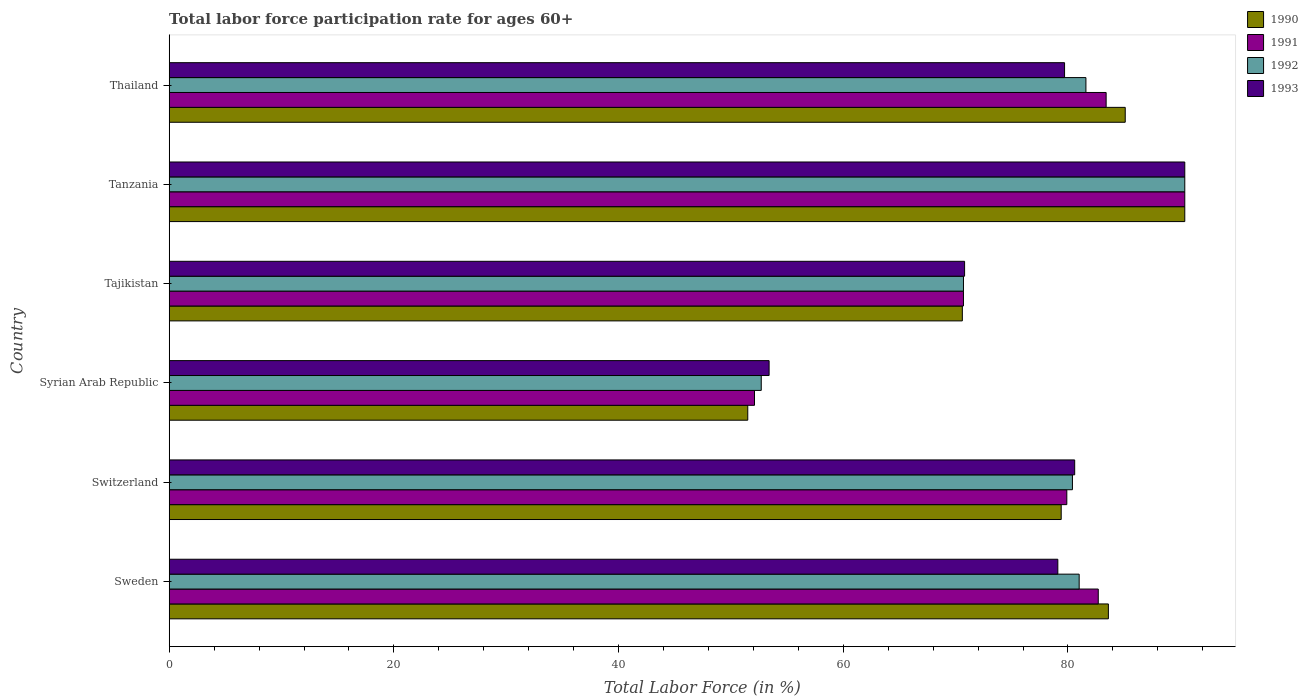How many different coloured bars are there?
Provide a short and direct response. 4. What is the label of the 1st group of bars from the top?
Your answer should be compact. Thailand. What is the labor force participation rate in 1990 in Sweden?
Make the answer very short. 83.6. Across all countries, what is the maximum labor force participation rate in 1991?
Your answer should be compact. 90.4. Across all countries, what is the minimum labor force participation rate in 1992?
Provide a succinct answer. 52.7. In which country was the labor force participation rate in 1992 maximum?
Provide a succinct answer. Tanzania. In which country was the labor force participation rate in 1991 minimum?
Provide a succinct answer. Syrian Arab Republic. What is the total labor force participation rate in 1990 in the graph?
Offer a very short reply. 460.6. What is the difference between the labor force participation rate in 1990 in Tajikistan and that in Thailand?
Give a very brief answer. -14.5. What is the difference between the labor force participation rate in 1992 in Tajikistan and the labor force participation rate in 1991 in Sweden?
Give a very brief answer. -12. What is the average labor force participation rate in 1991 per country?
Keep it short and to the point. 76.53. What is the difference between the labor force participation rate in 1990 and labor force participation rate in 1993 in Thailand?
Provide a short and direct response. 5.4. In how many countries, is the labor force participation rate in 1991 greater than 12 %?
Offer a terse response. 6. What is the ratio of the labor force participation rate in 1991 in Switzerland to that in Tajikistan?
Provide a succinct answer. 1.13. What is the difference between the highest and the second highest labor force participation rate in 1993?
Offer a very short reply. 9.8. What is the difference between the highest and the lowest labor force participation rate in 1990?
Offer a very short reply. 38.9. Is it the case that in every country, the sum of the labor force participation rate in 1990 and labor force participation rate in 1992 is greater than the sum of labor force participation rate in 1991 and labor force participation rate in 1993?
Offer a very short reply. No. What does the 1st bar from the top in Tajikistan represents?
Make the answer very short. 1993. How many bars are there?
Give a very brief answer. 24. Are all the bars in the graph horizontal?
Your answer should be very brief. Yes. How many countries are there in the graph?
Your answer should be very brief. 6. Does the graph contain any zero values?
Your answer should be compact. No. Does the graph contain grids?
Make the answer very short. No. Where does the legend appear in the graph?
Your answer should be very brief. Top right. How many legend labels are there?
Make the answer very short. 4. What is the title of the graph?
Your answer should be compact. Total labor force participation rate for ages 60+. What is the label or title of the X-axis?
Ensure brevity in your answer.  Total Labor Force (in %). What is the Total Labor Force (in %) of 1990 in Sweden?
Keep it short and to the point. 83.6. What is the Total Labor Force (in %) of 1991 in Sweden?
Provide a short and direct response. 82.7. What is the Total Labor Force (in %) of 1993 in Sweden?
Offer a very short reply. 79.1. What is the Total Labor Force (in %) of 1990 in Switzerland?
Give a very brief answer. 79.4. What is the Total Labor Force (in %) in 1991 in Switzerland?
Provide a succinct answer. 79.9. What is the Total Labor Force (in %) of 1992 in Switzerland?
Your response must be concise. 80.4. What is the Total Labor Force (in %) in 1993 in Switzerland?
Offer a very short reply. 80.6. What is the Total Labor Force (in %) of 1990 in Syrian Arab Republic?
Your answer should be compact. 51.5. What is the Total Labor Force (in %) in 1991 in Syrian Arab Republic?
Give a very brief answer. 52.1. What is the Total Labor Force (in %) in 1992 in Syrian Arab Republic?
Your answer should be very brief. 52.7. What is the Total Labor Force (in %) in 1993 in Syrian Arab Republic?
Offer a terse response. 53.4. What is the Total Labor Force (in %) of 1990 in Tajikistan?
Provide a short and direct response. 70.6. What is the Total Labor Force (in %) in 1991 in Tajikistan?
Provide a short and direct response. 70.7. What is the Total Labor Force (in %) of 1992 in Tajikistan?
Your response must be concise. 70.7. What is the Total Labor Force (in %) in 1993 in Tajikistan?
Your answer should be compact. 70.8. What is the Total Labor Force (in %) in 1990 in Tanzania?
Provide a succinct answer. 90.4. What is the Total Labor Force (in %) in 1991 in Tanzania?
Your response must be concise. 90.4. What is the Total Labor Force (in %) of 1992 in Tanzania?
Provide a short and direct response. 90.4. What is the Total Labor Force (in %) in 1993 in Tanzania?
Ensure brevity in your answer.  90.4. What is the Total Labor Force (in %) in 1990 in Thailand?
Ensure brevity in your answer.  85.1. What is the Total Labor Force (in %) in 1991 in Thailand?
Give a very brief answer. 83.4. What is the Total Labor Force (in %) in 1992 in Thailand?
Ensure brevity in your answer.  81.6. What is the Total Labor Force (in %) in 1993 in Thailand?
Keep it short and to the point. 79.7. Across all countries, what is the maximum Total Labor Force (in %) of 1990?
Ensure brevity in your answer.  90.4. Across all countries, what is the maximum Total Labor Force (in %) of 1991?
Your response must be concise. 90.4. Across all countries, what is the maximum Total Labor Force (in %) in 1992?
Provide a short and direct response. 90.4. Across all countries, what is the maximum Total Labor Force (in %) in 1993?
Provide a short and direct response. 90.4. Across all countries, what is the minimum Total Labor Force (in %) in 1990?
Make the answer very short. 51.5. Across all countries, what is the minimum Total Labor Force (in %) in 1991?
Your answer should be very brief. 52.1. Across all countries, what is the minimum Total Labor Force (in %) of 1992?
Offer a terse response. 52.7. Across all countries, what is the minimum Total Labor Force (in %) of 1993?
Offer a very short reply. 53.4. What is the total Total Labor Force (in %) in 1990 in the graph?
Your response must be concise. 460.6. What is the total Total Labor Force (in %) in 1991 in the graph?
Your answer should be very brief. 459.2. What is the total Total Labor Force (in %) of 1992 in the graph?
Offer a terse response. 456.8. What is the total Total Labor Force (in %) in 1993 in the graph?
Ensure brevity in your answer.  454. What is the difference between the Total Labor Force (in %) in 1990 in Sweden and that in Switzerland?
Make the answer very short. 4.2. What is the difference between the Total Labor Force (in %) in 1991 in Sweden and that in Switzerland?
Provide a succinct answer. 2.8. What is the difference between the Total Labor Force (in %) of 1993 in Sweden and that in Switzerland?
Give a very brief answer. -1.5. What is the difference between the Total Labor Force (in %) of 1990 in Sweden and that in Syrian Arab Republic?
Your response must be concise. 32.1. What is the difference between the Total Labor Force (in %) in 1991 in Sweden and that in Syrian Arab Republic?
Offer a very short reply. 30.6. What is the difference between the Total Labor Force (in %) in 1992 in Sweden and that in Syrian Arab Republic?
Offer a terse response. 28.3. What is the difference between the Total Labor Force (in %) in 1993 in Sweden and that in Syrian Arab Republic?
Provide a short and direct response. 25.7. What is the difference between the Total Labor Force (in %) in 1990 in Sweden and that in Tajikistan?
Your response must be concise. 13. What is the difference between the Total Labor Force (in %) of 1991 in Sweden and that in Tajikistan?
Your answer should be very brief. 12. What is the difference between the Total Labor Force (in %) of 1992 in Sweden and that in Tajikistan?
Your response must be concise. 10.3. What is the difference between the Total Labor Force (in %) in 1990 in Sweden and that in Tanzania?
Offer a terse response. -6.8. What is the difference between the Total Labor Force (in %) in 1991 in Sweden and that in Tanzania?
Offer a very short reply. -7.7. What is the difference between the Total Labor Force (in %) in 1993 in Sweden and that in Tanzania?
Give a very brief answer. -11.3. What is the difference between the Total Labor Force (in %) of 1990 in Sweden and that in Thailand?
Provide a short and direct response. -1.5. What is the difference between the Total Labor Force (in %) in 1991 in Sweden and that in Thailand?
Your answer should be very brief. -0.7. What is the difference between the Total Labor Force (in %) of 1993 in Sweden and that in Thailand?
Provide a succinct answer. -0.6. What is the difference between the Total Labor Force (in %) in 1990 in Switzerland and that in Syrian Arab Republic?
Your response must be concise. 27.9. What is the difference between the Total Labor Force (in %) of 1991 in Switzerland and that in Syrian Arab Republic?
Your response must be concise. 27.8. What is the difference between the Total Labor Force (in %) of 1992 in Switzerland and that in Syrian Arab Republic?
Ensure brevity in your answer.  27.7. What is the difference between the Total Labor Force (in %) of 1993 in Switzerland and that in Syrian Arab Republic?
Offer a very short reply. 27.2. What is the difference between the Total Labor Force (in %) of 1992 in Switzerland and that in Tanzania?
Your response must be concise. -10. What is the difference between the Total Labor Force (in %) of 1990 in Switzerland and that in Thailand?
Your answer should be compact. -5.7. What is the difference between the Total Labor Force (in %) in 1990 in Syrian Arab Republic and that in Tajikistan?
Provide a succinct answer. -19.1. What is the difference between the Total Labor Force (in %) in 1991 in Syrian Arab Republic and that in Tajikistan?
Provide a succinct answer. -18.6. What is the difference between the Total Labor Force (in %) in 1993 in Syrian Arab Republic and that in Tajikistan?
Provide a short and direct response. -17.4. What is the difference between the Total Labor Force (in %) of 1990 in Syrian Arab Republic and that in Tanzania?
Give a very brief answer. -38.9. What is the difference between the Total Labor Force (in %) of 1991 in Syrian Arab Republic and that in Tanzania?
Provide a succinct answer. -38.3. What is the difference between the Total Labor Force (in %) in 1992 in Syrian Arab Republic and that in Tanzania?
Keep it short and to the point. -37.7. What is the difference between the Total Labor Force (in %) in 1993 in Syrian Arab Republic and that in Tanzania?
Offer a very short reply. -37. What is the difference between the Total Labor Force (in %) in 1990 in Syrian Arab Republic and that in Thailand?
Provide a short and direct response. -33.6. What is the difference between the Total Labor Force (in %) in 1991 in Syrian Arab Republic and that in Thailand?
Keep it short and to the point. -31.3. What is the difference between the Total Labor Force (in %) of 1992 in Syrian Arab Republic and that in Thailand?
Offer a very short reply. -28.9. What is the difference between the Total Labor Force (in %) of 1993 in Syrian Arab Republic and that in Thailand?
Ensure brevity in your answer.  -26.3. What is the difference between the Total Labor Force (in %) in 1990 in Tajikistan and that in Tanzania?
Ensure brevity in your answer.  -19.8. What is the difference between the Total Labor Force (in %) in 1991 in Tajikistan and that in Tanzania?
Your answer should be very brief. -19.7. What is the difference between the Total Labor Force (in %) in 1992 in Tajikistan and that in Tanzania?
Provide a succinct answer. -19.7. What is the difference between the Total Labor Force (in %) in 1993 in Tajikistan and that in Tanzania?
Your response must be concise. -19.6. What is the difference between the Total Labor Force (in %) in 1993 in Tajikistan and that in Thailand?
Offer a terse response. -8.9. What is the difference between the Total Labor Force (in %) in 1990 in Tanzania and that in Thailand?
Make the answer very short. 5.3. What is the difference between the Total Labor Force (in %) in 1991 in Tanzania and that in Thailand?
Offer a terse response. 7. What is the difference between the Total Labor Force (in %) of 1992 in Tanzania and that in Thailand?
Offer a terse response. 8.8. What is the difference between the Total Labor Force (in %) of 1993 in Tanzania and that in Thailand?
Give a very brief answer. 10.7. What is the difference between the Total Labor Force (in %) of 1990 in Sweden and the Total Labor Force (in %) of 1992 in Switzerland?
Your answer should be very brief. 3.2. What is the difference between the Total Labor Force (in %) in 1990 in Sweden and the Total Labor Force (in %) in 1993 in Switzerland?
Provide a succinct answer. 3. What is the difference between the Total Labor Force (in %) in 1991 in Sweden and the Total Labor Force (in %) in 1992 in Switzerland?
Your answer should be compact. 2.3. What is the difference between the Total Labor Force (in %) of 1991 in Sweden and the Total Labor Force (in %) of 1993 in Switzerland?
Your answer should be compact. 2.1. What is the difference between the Total Labor Force (in %) in 1990 in Sweden and the Total Labor Force (in %) in 1991 in Syrian Arab Republic?
Your answer should be compact. 31.5. What is the difference between the Total Labor Force (in %) in 1990 in Sweden and the Total Labor Force (in %) in 1992 in Syrian Arab Republic?
Offer a terse response. 30.9. What is the difference between the Total Labor Force (in %) in 1990 in Sweden and the Total Labor Force (in %) in 1993 in Syrian Arab Republic?
Provide a succinct answer. 30.2. What is the difference between the Total Labor Force (in %) of 1991 in Sweden and the Total Labor Force (in %) of 1992 in Syrian Arab Republic?
Provide a succinct answer. 30. What is the difference between the Total Labor Force (in %) of 1991 in Sweden and the Total Labor Force (in %) of 1993 in Syrian Arab Republic?
Provide a succinct answer. 29.3. What is the difference between the Total Labor Force (in %) in 1992 in Sweden and the Total Labor Force (in %) in 1993 in Syrian Arab Republic?
Keep it short and to the point. 27.6. What is the difference between the Total Labor Force (in %) in 1990 in Sweden and the Total Labor Force (in %) in 1991 in Tajikistan?
Provide a short and direct response. 12.9. What is the difference between the Total Labor Force (in %) in 1990 in Sweden and the Total Labor Force (in %) in 1993 in Tajikistan?
Keep it short and to the point. 12.8. What is the difference between the Total Labor Force (in %) in 1991 in Sweden and the Total Labor Force (in %) in 1992 in Tajikistan?
Your response must be concise. 12. What is the difference between the Total Labor Force (in %) of 1991 in Sweden and the Total Labor Force (in %) of 1993 in Tajikistan?
Keep it short and to the point. 11.9. What is the difference between the Total Labor Force (in %) in 1992 in Sweden and the Total Labor Force (in %) in 1993 in Tajikistan?
Ensure brevity in your answer.  10.2. What is the difference between the Total Labor Force (in %) of 1990 in Sweden and the Total Labor Force (in %) of 1993 in Tanzania?
Your response must be concise. -6.8. What is the difference between the Total Labor Force (in %) in 1992 in Sweden and the Total Labor Force (in %) in 1993 in Tanzania?
Provide a short and direct response. -9.4. What is the difference between the Total Labor Force (in %) of 1990 in Sweden and the Total Labor Force (in %) of 1992 in Thailand?
Your response must be concise. 2. What is the difference between the Total Labor Force (in %) in 1990 in Sweden and the Total Labor Force (in %) in 1993 in Thailand?
Provide a short and direct response. 3.9. What is the difference between the Total Labor Force (in %) of 1991 in Sweden and the Total Labor Force (in %) of 1993 in Thailand?
Your answer should be very brief. 3. What is the difference between the Total Labor Force (in %) of 1990 in Switzerland and the Total Labor Force (in %) of 1991 in Syrian Arab Republic?
Provide a short and direct response. 27.3. What is the difference between the Total Labor Force (in %) in 1990 in Switzerland and the Total Labor Force (in %) in 1992 in Syrian Arab Republic?
Give a very brief answer. 26.7. What is the difference between the Total Labor Force (in %) of 1990 in Switzerland and the Total Labor Force (in %) of 1993 in Syrian Arab Republic?
Offer a very short reply. 26. What is the difference between the Total Labor Force (in %) of 1991 in Switzerland and the Total Labor Force (in %) of 1992 in Syrian Arab Republic?
Offer a terse response. 27.2. What is the difference between the Total Labor Force (in %) in 1991 in Switzerland and the Total Labor Force (in %) in 1993 in Syrian Arab Republic?
Your response must be concise. 26.5. What is the difference between the Total Labor Force (in %) of 1990 in Switzerland and the Total Labor Force (in %) of 1991 in Tajikistan?
Give a very brief answer. 8.7. What is the difference between the Total Labor Force (in %) in 1990 in Switzerland and the Total Labor Force (in %) in 1993 in Tajikistan?
Offer a very short reply. 8.6. What is the difference between the Total Labor Force (in %) in 1991 in Switzerland and the Total Labor Force (in %) in 1992 in Tajikistan?
Keep it short and to the point. 9.2. What is the difference between the Total Labor Force (in %) of 1990 in Switzerland and the Total Labor Force (in %) of 1991 in Tanzania?
Offer a terse response. -11. What is the difference between the Total Labor Force (in %) of 1992 in Switzerland and the Total Labor Force (in %) of 1993 in Tanzania?
Provide a succinct answer. -10. What is the difference between the Total Labor Force (in %) in 1990 in Switzerland and the Total Labor Force (in %) in 1991 in Thailand?
Your answer should be very brief. -4. What is the difference between the Total Labor Force (in %) of 1991 in Switzerland and the Total Labor Force (in %) of 1992 in Thailand?
Offer a terse response. -1.7. What is the difference between the Total Labor Force (in %) in 1991 in Switzerland and the Total Labor Force (in %) in 1993 in Thailand?
Ensure brevity in your answer.  0.2. What is the difference between the Total Labor Force (in %) of 1990 in Syrian Arab Republic and the Total Labor Force (in %) of 1991 in Tajikistan?
Offer a very short reply. -19.2. What is the difference between the Total Labor Force (in %) of 1990 in Syrian Arab Republic and the Total Labor Force (in %) of 1992 in Tajikistan?
Give a very brief answer. -19.2. What is the difference between the Total Labor Force (in %) in 1990 in Syrian Arab Republic and the Total Labor Force (in %) in 1993 in Tajikistan?
Keep it short and to the point. -19.3. What is the difference between the Total Labor Force (in %) in 1991 in Syrian Arab Republic and the Total Labor Force (in %) in 1992 in Tajikistan?
Provide a succinct answer. -18.6. What is the difference between the Total Labor Force (in %) in 1991 in Syrian Arab Republic and the Total Labor Force (in %) in 1993 in Tajikistan?
Your answer should be compact. -18.7. What is the difference between the Total Labor Force (in %) in 1992 in Syrian Arab Republic and the Total Labor Force (in %) in 1993 in Tajikistan?
Keep it short and to the point. -18.1. What is the difference between the Total Labor Force (in %) of 1990 in Syrian Arab Republic and the Total Labor Force (in %) of 1991 in Tanzania?
Your answer should be compact. -38.9. What is the difference between the Total Labor Force (in %) of 1990 in Syrian Arab Republic and the Total Labor Force (in %) of 1992 in Tanzania?
Provide a short and direct response. -38.9. What is the difference between the Total Labor Force (in %) of 1990 in Syrian Arab Republic and the Total Labor Force (in %) of 1993 in Tanzania?
Your response must be concise. -38.9. What is the difference between the Total Labor Force (in %) in 1991 in Syrian Arab Republic and the Total Labor Force (in %) in 1992 in Tanzania?
Give a very brief answer. -38.3. What is the difference between the Total Labor Force (in %) in 1991 in Syrian Arab Republic and the Total Labor Force (in %) in 1993 in Tanzania?
Your answer should be very brief. -38.3. What is the difference between the Total Labor Force (in %) in 1992 in Syrian Arab Republic and the Total Labor Force (in %) in 1993 in Tanzania?
Your answer should be compact. -37.7. What is the difference between the Total Labor Force (in %) in 1990 in Syrian Arab Republic and the Total Labor Force (in %) in 1991 in Thailand?
Provide a succinct answer. -31.9. What is the difference between the Total Labor Force (in %) of 1990 in Syrian Arab Republic and the Total Labor Force (in %) of 1992 in Thailand?
Your response must be concise. -30.1. What is the difference between the Total Labor Force (in %) of 1990 in Syrian Arab Republic and the Total Labor Force (in %) of 1993 in Thailand?
Your response must be concise. -28.2. What is the difference between the Total Labor Force (in %) in 1991 in Syrian Arab Republic and the Total Labor Force (in %) in 1992 in Thailand?
Your response must be concise. -29.5. What is the difference between the Total Labor Force (in %) of 1991 in Syrian Arab Republic and the Total Labor Force (in %) of 1993 in Thailand?
Ensure brevity in your answer.  -27.6. What is the difference between the Total Labor Force (in %) of 1992 in Syrian Arab Republic and the Total Labor Force (in %) of 1993 in Thailand?
Provide a short and direct response. -27. What is the difference between the Total Labor Force (in %) of 1990 in Tajikistan and the Total Labor Force (in %) of 1991 in Tanzania?
Make the answer very short. -19.8. What is the difference between the Total Labor Force (in %) in 1990 in Tajikistan and the Total Labor Force (in %) in 1992 in Tanzania?
Ensure brevity in your answer.  -19.8. What is the difference between the Total Labor Force (in %) in 1990 in Tajikistan and the Total Labor Force (in %) in 1993 in Tanzania?
Your response must be concise. -19.8. What is the difference between the Total Labor Force (in %) in 1991 in Tajikistan and the Total Labor Force (in %) in 1992 in Tanzania?
Give a very brief answer. -19.7. What is the difference between the Total Labor Force (in %) of 1991 in Tajikistan and the Total Labor Force (in %) of 1993 in Tanzania?
Provide a short and direct response. -19.7. What is the difference between the Total Labor Force (in %) of 1992 in Tajikistan and the Total Labor Force (in %) of 1993 in Tanzania?
Provide a short and direct response. -19.7. What is the difference between the Total Labor Force (in %) of 1990 in Tajikistan and the Total Labor Force (in %) of 1991 in Thailand?
Provide a succinct answer. -12.8. What is the difference between the Total Labor Force (in %) of 1990 in Tajikistan and the Total Labor Force (in %) of 1992 in Thailand?
Offer a very short reply. -11. What is the difference between the Total Labor Force (in %) of 1990 in Tajikistan and the Total Labor Force (in %) of 1993 in Thailand?
Provide a short and direct response. -9.1. What is the difference between the Total Labor Force (in %) of 1990 in Tanzania and the Total Labor Force (in %) of 1991 in Thailand?
Provide a succinct answer. 7. What is the difference between the Total Labor Force (in %) in 1992 in Tanzania and the Total Labor Force (in %) in 1993 in Thailand?
Provide a succinct answer. 10.7. What is the average Total Labor Force (in %) in 1990 per country?
Keep it short and to the point. 76.77. What is the average Total Labor Force (in %) in 1991 per country?
Ensure brevity in your answer.  76.53. What is the average Total Labor Force (in %) in 1992 per country?
Make the answer very short. 76.13. What is the average Total Labor Force (in %) of 1993 per country?
Offer a very short reply. 75.67. What is the difference between the Total Labor Force (in %) of 1990 and Total Labor Force (in %) of 1991 in Sweden?
Provide a short and direct response. 0.9. What is the difference between the Total Labor Force (in %) in 1990 and Total Labor Force (in %) in 1993 in Sweden?
Provide a succinct answer. 4.5. What is the difference between the Total Labor Force (in %) of 1991 and Total Labor Force (in %) of 1993 in Sweden?
Give a very brief answer. 3.6. What is the difference between the Total Labor Force (in %) of 1992 and Total Labor Force (in %) of 1993 in Sweden?
Offer a very short reply. 1.9. What is the difference between the Total Labor Force (in %) in 1990 and Total Labor Force (in %) in 1991 in Switzerland?
Give a very brief answer. -0.5. What is the difference between the Total Labor Force (in %) of 1990 and Total Labor Force (in %) of 1992 in Switzerland?
Your response must be concise. -1. What is the difference between the Total Labor Force (in %) of 1991 and Total Labor Force (in %) of 1992 in Switzerland?
Provide a short and direct response. -0.5. What is the difference between the Total Labor Force (in %) of 1990 and Total Labor Force (in %) of 1992 in Syrian Arab Republic?
Provide a succinct answer. -1.2. What is the difference between the Total Labor Force (in %) of 1990 and Total Labor Force (in %) of 1993 in Syrian Arab Republic?
Your answer should be very brief. -1.9. What is the difference between the Total Labor Force (in %) in 1991 and Total Labor Force (in %) in 1992 in Syrian Arab Republic?
Provide a short and direct response. -0.6. What is the difference between the Total Labor Force (in %) in 1991 and Total Labor Force (in %) in 1993 in Syrian Arab Republic?
Keep it short and to the point. -1.3. What is the difference between the Total Labor Force (in %) of 1992 and Total Labor Force (in %) of 1993 in Syrian Arab Republic?
Offer a very short reply. -0.7. What is the difference between the Total Labor Force (in %) in 1990 and Total Labor Force (in %) in 1991 in Tajikistan?
Your answer should be very brief. -0.1. What is the difference between the Total Labor Force (in %) of 1990 and Total Labor Force (in %) of 1992 in Tajikistan?
Your answer should be very brief. -0.1. What is the difference between the Total Labor Force (in %) in 1990 and Total Labor Force (in %) in 1993 in Tajikistan?
Offer a terse response. -0.2. What is the difference between the Total Labor Force (in %) of 1990 and Total Labor Force (in %) of 1991 in Tanzania?
Provide a short and direct response. 0. What is the difference between the Total Labor Force (in %) of 1991 and Total Labor Force (in %) of 1993 in Tanzania?
Offer a very short reply. 0. What is the difference between the Total Labor Force (in %) in 1992 and Total Labor Force (in %) in 1993 in Tanzania?
Your answer should be compact. 0. What is the difference between the Total Labor Force (in %) of 1990 and Total Labor Force (in %) of 1991 in Thailand?
Provide a succinct answer. 1.7. What is the difference between the Total Labor Force (in %) in 1990 and Total Labor Force (in %) in 1992 in Thailand?
Your response must be concise. 3.5. What is the difference between the Total Labor Force (in %) in 1990 and Total Labor Force (in %) in 1993 in Thailand?
Ensure brevity in your answer.  5.4. What is the difference between the Total Labor Force (in %) in 1991 and Total Labor Force (in %) in 1992 in Thailand?
Offer a terse response. 1.8. What is the ratio of the Total Labor Force (in %) of 1990 in Sweden to that in Switzerland?
Ensure brevity in your answer.  1.05. What is the ratio of the Total Labor Force (in %) of 1991 in Sweden to that in Switzerland?
Provide a short and direct response. 1.03. What is the ratio of the Total Labor Force (in %) of 1992 in Sweden to that in Switzerland?
Offer a very short reply. 1.01. What is the ratio of the Total Labor Force (in %) in 1993 in Sweden to that in Switzerland?
Provide a succinct answer. 0.98. What is the ratio of the Total Labor Force (in %) in 1990 in Sweden to that in Syrian Arab Republic?
Give a very brief answer. 1.62. What is the ratio of the Total Labor Force (in %) of 1991 in Sweden to that in Syrian Arab Republic?
Ensure brevity in your answer.  1.59. What is the ratio of the Total Labor Force (in %) in 1992 in Sweden to that in Syrian Arab Republic?
Your response must be concise. 1.54. What is the ratio of the Total Labor Force (in %) of 1993 in Sweden to that in Syrian Arab Republic?
Make the answer very short. 1.48. What is the ratio of the Total Labor Force (in %) of 1990 in Sweden to that in Tajikistan?
Give a very brief answer. 1.18. What is the ratio of the Total Labor Force (in %) in 1991 in Sweden to that in Tajikistan?
Your answer should be very brief. 1.17. What is the ratio of the Total Labor Force (in %) in 1992 in Sweden to that in Tajikistan?
Provide a succinct answer. 1.15. What is the ratio of the Total Labor Force (in %) in 1993 in Sweden to that in Tajikistan?
Your answer should be compact. 1.12. What is the ratio of the Total Labor Force (in %) of 1990 in Sweden to that in Tanzania?
Your answer should be compact. 0.92. What is the ratio of the Total Labor Force (in %) of 1991 in Sweden to that in Tanzania?
Offer a terse response. 0.91. What is the ratio of the Total Labor Force (in %) of 1992 in Sweden to that in Tanzania?
Ensure brevity in your answer.  0.9. What is the ratio of the Total Labor Force (in %) of 1990 in Sweden to that in Thailand?
Provide a short and direct response. 0.98. What is the ratio of the Total Labor Force (in %) of 1991 in Sweden to that in Thailand?
Offer a very short reply. 0.99. What is the ratio of the Total Labor Force (in %) of 1993 in Sweden to that in Thailand?
Your response must be concise. 0.99. What is the ratio of the Total Labor Force (in %) in 1990 in Switzerland to that in Syrian Arab Republic?
Make the answer very short. 1.54. What is the ratio of the Total Labor Force (in %) of 1991 in Switzerland to that in Syrian Arab Republic?
Provide a short and direct response. 1.53. What is the ratio of the Total Labor Force (in %) in 1992 in Switzerland to that in Syrian Arab Republic?
Your answer should be compact. 1.53. What is the ratio of the Total Labor Force (in %) of 1993 in Switzerland to that in Syrian Arab Republic?
Keep it short and to the point. 1.51. What is the ratio of the Total Labor Force (in %) in 1990 in Switzerland to that in Tajikistan?
Keep it short and to the point. 1.12. What is the ratio of the Total Labor Force (in %) of 1991 in Switzerland to that in Tajikistan?
Provide a succinct answer. 1.13. What is the ratio of the Total Labor Force (in %) in 1992 in Switzerland to that in Tajikistan?
Your response must be concise. 1.14. What is the ratio of the Total Labor Force (in %) in 1993 in Switzerland to that in Tajikistan?
Make the answer very short. 1.14. What is the ratio of the Total Labor Force (in %) in 1990 in Switzerland to that in Tanzania?
Your answer should be very brief. 0.88. What is the ratio of the Total Labor Force (in %) in 1991 in Switzerland to that in Tanzania?
Offer a terse response. 0.88. What is the ratio of the Total Labor Force (in %) in 1992 in Switzerland to that in Tanzania?
Ensure brevity in your answer.  0.89. What is the ratio of the Total Labor Force (in %) in 1993 in Switzerland to that in Tanzania?
Offer a terse response. 0.89. What is the ratio of the Total Labor Force (in %) in 1990 in Switzerland to that in Thailand?
Offer a terse response. 0.93. What is the ratio of the Total Labor Force (in %) of 1991 in Switzerland to that in Thailand?
Your answer should be very brief. 0.96. What is the ratio of the Total Labor Force (in %) of 1993 in Switzerland to that in Thailand?
Give a very brief answer. 1.01. What is the ratio of the Total Labor Force (in %) of 1990 in Syrian Arab Republic to that in Tajikistan?
Your answer should be very brief. 0.73. What is the ratio of the Total Labor Force (in %) of 1991 in Syrian Arab Republic to that in Tajikistan?
Your answer should be compact. 0.74. What is the ratio of the Total Labor Force (in %) of 1992 in Syrian Arab Republic to that in Tajikistan?
Offer a terse response. 0.75. What is the ratio of the Total Labor Force (in %) of 1993 in Syrian Arab Republic to that in Tajikistan?
Give a very brief answer. 0.75. What is the ratio of the Total Labor Force (in %) of 1990 in Syrian Arab Republic to that in Tanzania?
Make the answer very short. 0.57. What is the ratio of the Total Labor Force (in %) in 1991 in Syrian Arab Republic to that in Tanzania?
Keep it short and to the point. 0.58. What is the ratio of the Total Labor Force (in %) of 1992 in Syrian Arab Republic to that in Tanzania?
Give a very brief answer. 0.58. What is the ratio of the Total Labor Force (in %) of 1993 in Syrian Arab Republic to that in Tanzania?
Give a very brief answer. 0.59. What is the ratio of the Total Labor Force (in %) of 1990 in Syrian Arab Republic to that in Thailand?
Offer a terse response. 0.61. What is the ratio of the Total Labor Force (in %) in 1991 in Syrian Arab Republic to that in Thailand?
Provide a short and direct response. 0.62. What is the ratio of the Total Labor Force (in %) in 1992 in Syrian Arab Republic to that in Thailand?
Your response must be concise. 0.65. What is the ratio of the Total Labor Force (in %) in 1993 in Syrian Arab Republic to that in Thailand?
Ensure brevity in your answer.  0.67. What is the ratio of the Total Labor Force (in %) in 1990 in Tajikistan to that in Tanzania?
Give a very brief answer. 0.78. What is the ratio of the Total Labor Force (in %) in 1991 in Tajikistan to that in Tanzania?
Provide a succinct answer. 0.78. What is the ratio of the Total Labor Force (in %) of 1992 in Tajikistan to that in Tanzania?
Your answer should be compact. 0.78. What is the ratio of the Total Labor Force (in %) of 1993 in Tajikistan to that in Tanzania?
Your response must be concise. 0.78. What is the ratio of the Total Labor Force (in %) in 1990 in Tajikistan to that in Thailand?
Make the answer very short. 0.83. What is the ratio of the Total Labor Force (in %) in 1991 in Tajikistan to that in Thailand?
Make the answer very short. 0.85. What is the ratio of the Total Labor Force (in %) in 1992 in Tajikistan to that in Thailand?
Provide a succinct answer. 0.87. What is the ratio of the Total Labor Force (in %) of 1993 in Tajikistan to that in Thailand?
Provide a succinct answer. 0.89. What is the ratio of the Total Labor Force (in %) of 1990 in Tanzania to that in Thailand?
Your answer should be compact. 1.06. What is the ratio of the Total Labor Force (in %) in 1991 in Tanzania to that in Thailand?
Offer a terse response. 1.08. What is the ratio of the Total Labor Force (in %) in 1992 in Tanzania to that in Thailand?
Give a very brief answer. 1.11. What is the ratio of the Total Labor Force (in %) of 1993 in Tanzania to that in Thailand?
Make the answer very short. 1.13. What is the difference between the highest and the second highest Total Labor Force (in %) of 1992?
Provide a short and direct response. 8.8. What is the difference between the highest and the lowest Total Labor Force (in %) in 1990?
Give a very brief answer. 38.9. What is the difference between the highest and the lowest Total Labor Force (in %) in 1991?
Keep it short and to the point. 38.3. What is the difference between the highest and the lowest Total Labor Force (in %) in 1992?
Make the answer very short. 37.7. 